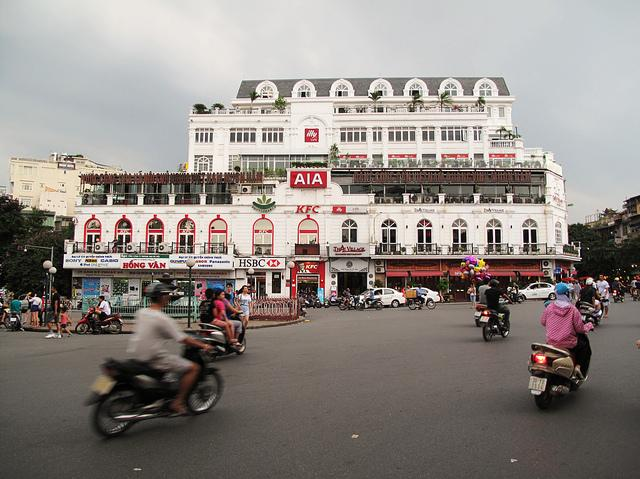What sort of bird meats are sold in this large building among other things? Please explain your reasoning. chicken. One of the store names present in this street scene is kfc. kfc is known for it's fried chicken. 